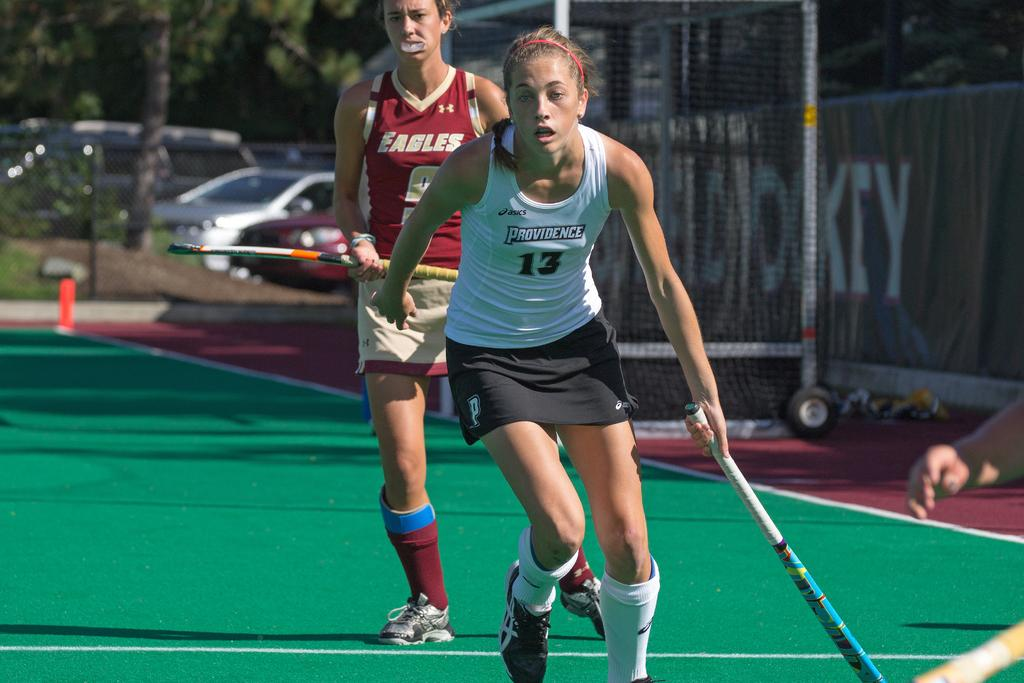<image>
Relay a brief, clear account of the picture shown. A girl wearing a red top with Eagles on it watches her opponent who is wearing a white top with Providence on it in a hockey match. 